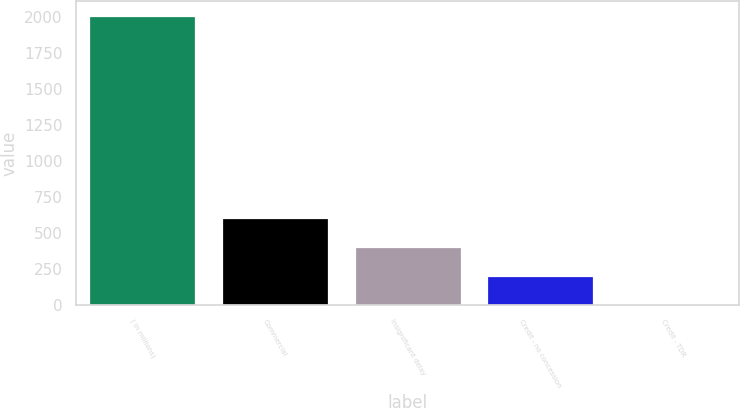Convert chart. <chart><loc_0><loc_0><loc_500><loc_500><bar_chart><fcel>( in millions)<fcel>Commercial<fcel>Insignificant delay<fcel>Credit - no concession<fcel>Credit - TDR<nl><fcel>2011<fcel>603.72<fcel>402.68<fcel>201.64<fcel>0.6<nl></chart> 